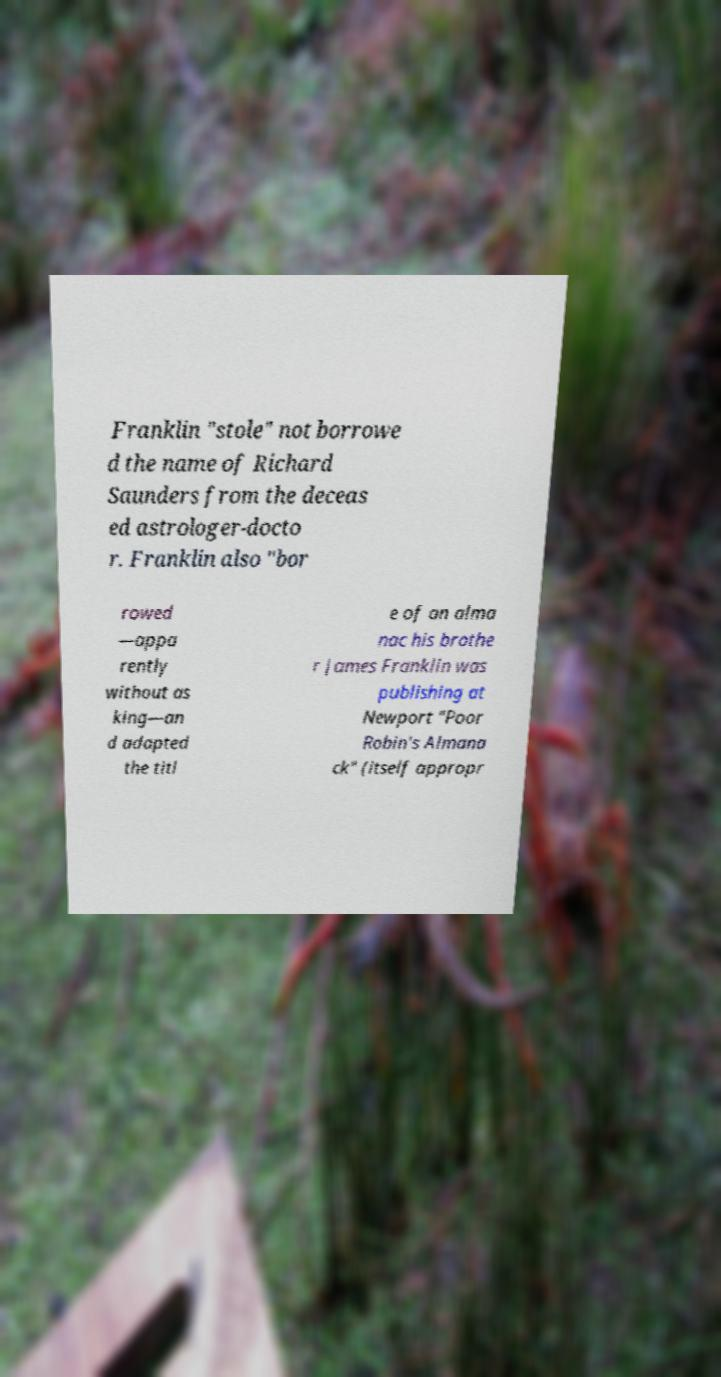There's text embedded in this image that I need extracted. Can you transcribe it verbatim? Franklin "stole" not borrowe d the name of Richard Saunders from the deceas ed astrologer-docto r. Franklin also "bor rowed —appa rently without as king—an d adapted the titl e of an alma nac his brothe r James Franklin was publishing at Newport "Poor Robin's Almana ck" (itself appropr 